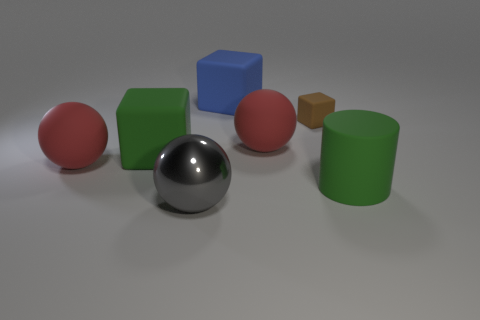Add 1 brown rubber blocks. How many objects exist? 8 Subtract all cylinders. How many objects are left? 6 Add 6 big cyan things. How many big cyan things exist? 6 Subtract 0 yellow cylinders. How many objects are left? 7 Subtract all green rubber objects. Subtract all big red matte objects. How many objects are left? 3 Add 5 small brown cubes. How many small brown cubes are left? 6 